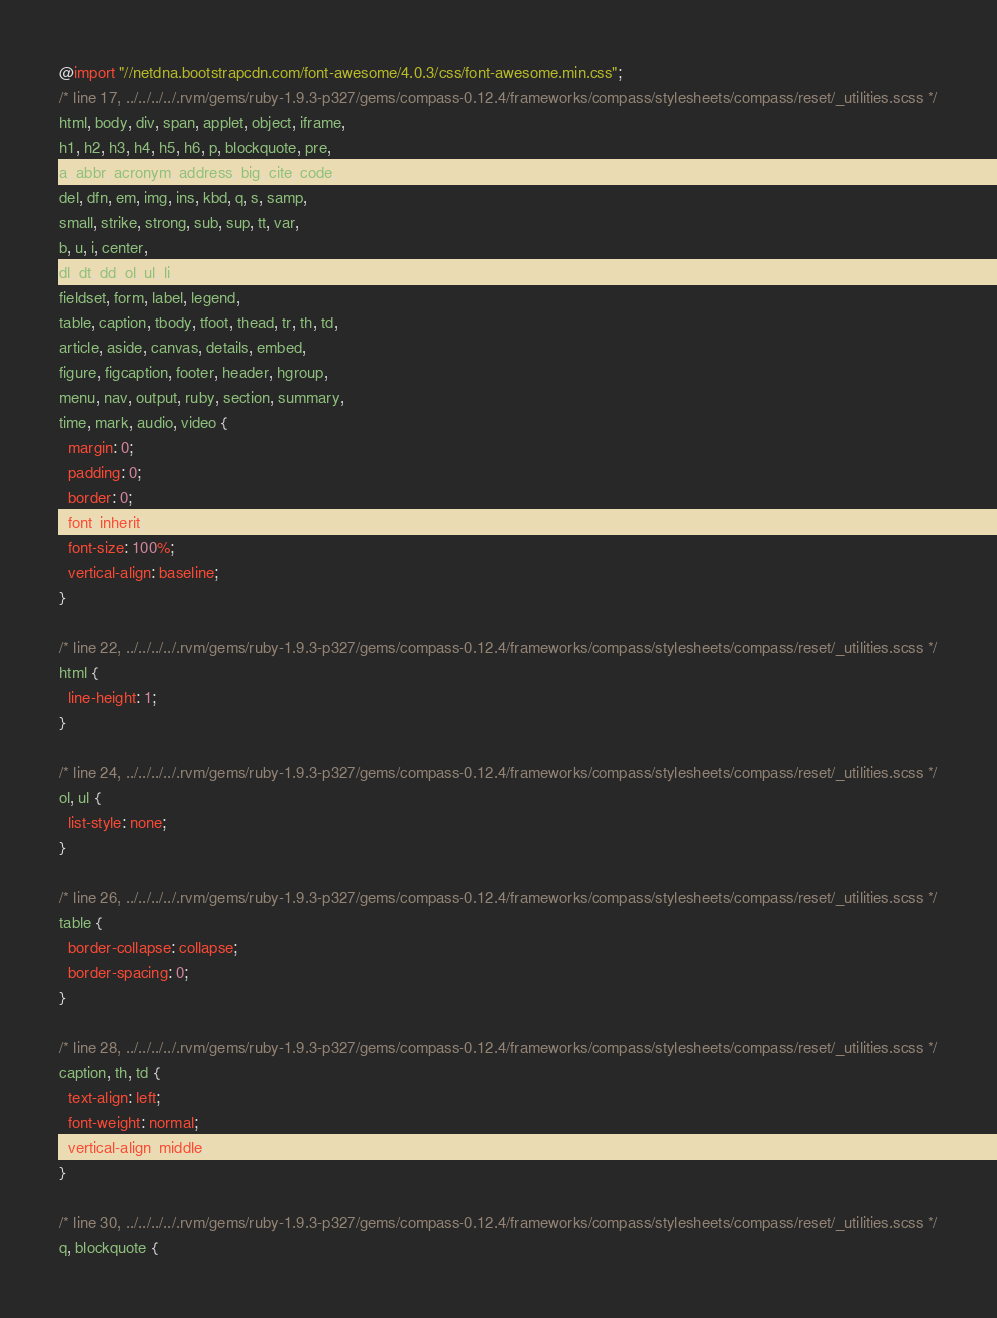<code> <loc_0><loc_0><loc_500><loc_500><_CSS_>@import "//netdna.bootstrapcdn.com/font-awesome/4.0.3/css/font-awesome.min.css";
/* line 17, ../../../../.rvm/gems/ruby-1.9.3-p327/gems/compass-0.12.4/frameworks/compass/stylesheets/compass/reset/_utilities.scss */
html, body, div, span, applet, object, iframe,
h1, h2, h3, h4, h5, h6, p, blockquote, pre,
a, abbr, acronym, address, big, cite, code,
del, dfn, em, img, ins, kbd, q, s, samp,
small, strike, strong, sub, sup, tt, var,
b, u, i, center,
dl, dt, dd, ol, ul, li,
fieldset, form, label, legend,
table, caption, tbody, tfoot, thead, tr, th, td,
article, aside, canvas, details, embed,
figure, figcaption, footer, header, hgroup,
menu, nav, output, ruby, section, summary,
time, mark, audio, video {
  margin: 0;
  padding: 0;
  border: 0;
  font: inherit;
  font-size: 100%;
  vertical-align: baseline;
}

/* line 22, ../../../../.rvm/gems/ruby-1.9.3-p327/gems/compass-0.12.4/frameworks/compass/stylesheets/compass/reset/_utilities.scss */
html {
  line-height: 1;
}

/* line 24, ../../../../.rvm/gems/ruby-1.9.3-p327/gems/compass-0.12.4/frameworks/compass/stylesheets/compass/reset/_utilities.scss */
ol, ul {
  list-style: none;
}

/* line 26, ../../../../.rvm/gems/ruby-1.9.3-p327/gems/compass-0.12.4/frameworks/compass/stylesheets/compass/reset/_utilities.scss */
table {
  border-collapse: collapse;
  border-spacing: 0;
}

/* line 28, ../../../../.rvm/gems/ruby-1.9.3-p327/gems/compass-0.12.4/frameworks/compass/stylesheets/compass/reset/_utilities.scss */
caption, th, td {
  text-align: left;
  font-weight: normal;
  vertical-align: middle;
}

/* line 30, ../../../../.rvm/gems/ruby-1.9.3-p327/gems/compass-0.12.4/frameworks/compass/stylesheets/compass/reset/_utilities.scss */
q, blockquote {</code> 